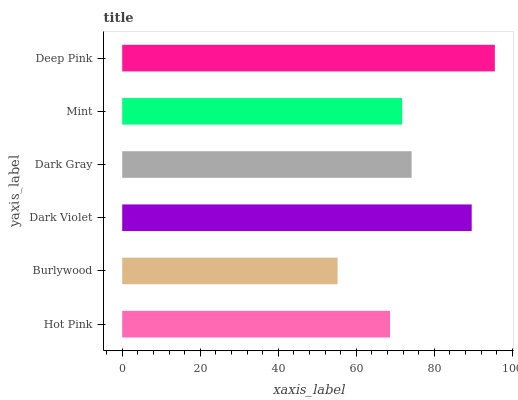Is Burlywood the minimum?
Answer yes or no. Yes. Is Deep Pink the maximum?
Answer yes or no. Yes. Is Dark Violet the minimum?
Answer yes or no. No. Is Dark Violet the maximum?
Answer yes or no. No. Is Dark Violet greater than Burlywood?
Answer yes or no. Yes. Is Burlywood less than Dark Violet?
Answer yes or no. Yes. Is Burlywood greater than Dark Violet?
Answer yes or no. No. Is Dark Violet less than Burlywood?
Answer yes or no. No. Is Dark Gray the high median?
Answer yes or no. Yes. Is Mint the low median?
Answer yes or no. Yes. Is Dark Violet the high median?
Answer yes or no. No. Is Burlywood the low median?
Answer yes or no. No. 